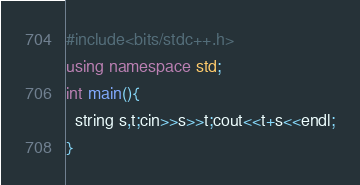<code> <loc_0><loc_0><loc_500><loc_500><_C++_>#include<bits/stdc++.h>
using namespace std;
int main(){
  string s,t;cin>>s>>t;cout<<t+s<<endl;
}</code> 